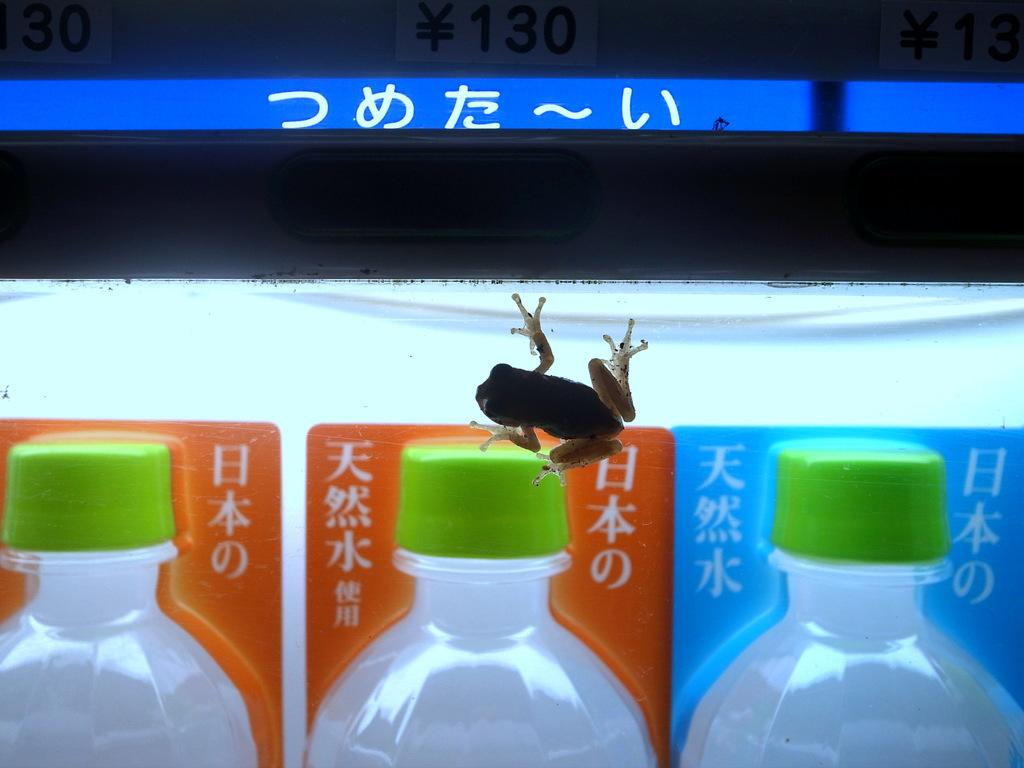What objects can be seen in the image? There are bottles and a frog in the image. Can you describe the frog in the image? The frog is a living creature in the image. What type of garden can be seen in the image? There is no garden present in the image; it only contains bottles and a frog. How many kites are visible in the image? There are no kites present in the image. 